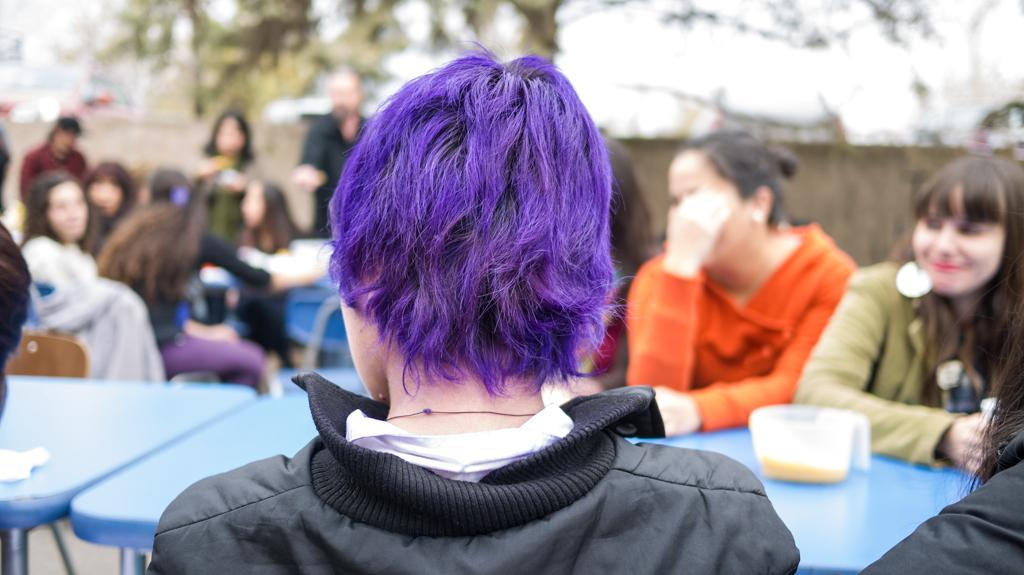What are the people in the image doing? The people in the image are sitting on chairs around tables. What is on the table in the image? There is a bowl placed on a table. What can be seen in the background of the image? There is a wall and trees in the background. Can you hear the beetle laughing in the image? There is no beetle or laughter present in the image. 